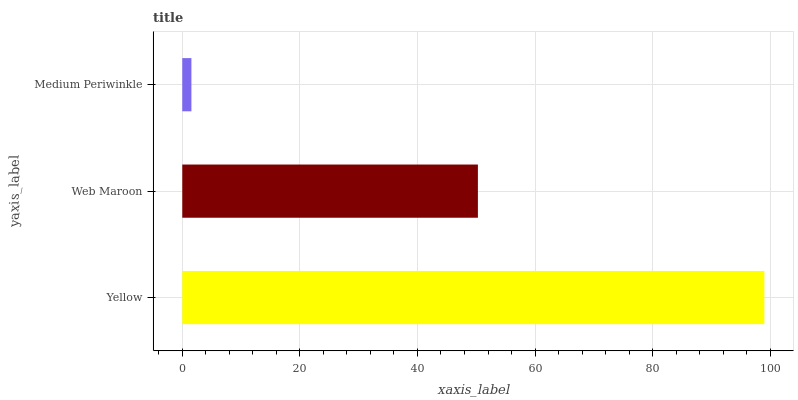Is Medium Periwinkle the minimum?
Answer yes or no. Yes. Is Yellow the maximum?
Answer yes or no. Yes. Is Web Maroon the minimum?
Answer yes or no. No. Is Web Maroon the maximum?
Answer yes or no. No. Is Yellow greater than Web Maroon?
Answer yes or no. Yes. Is Web Maroon less than Yellow?
Answer yes or no. Yes. Is Web Maroon greater than Yellow?
Answer yes or no. No. Is Yellow less than Web Maroon?
Answer yes or no. No. Is Web Maroon the high median?
Answer yes or no. Yes. Is Web Maroon the low median?
Answer yes or no. Yes. Is Medium Periwinkle the high median?
Answer yes or no. No. Is Yellow the low median?
Answer yes or no. No. 